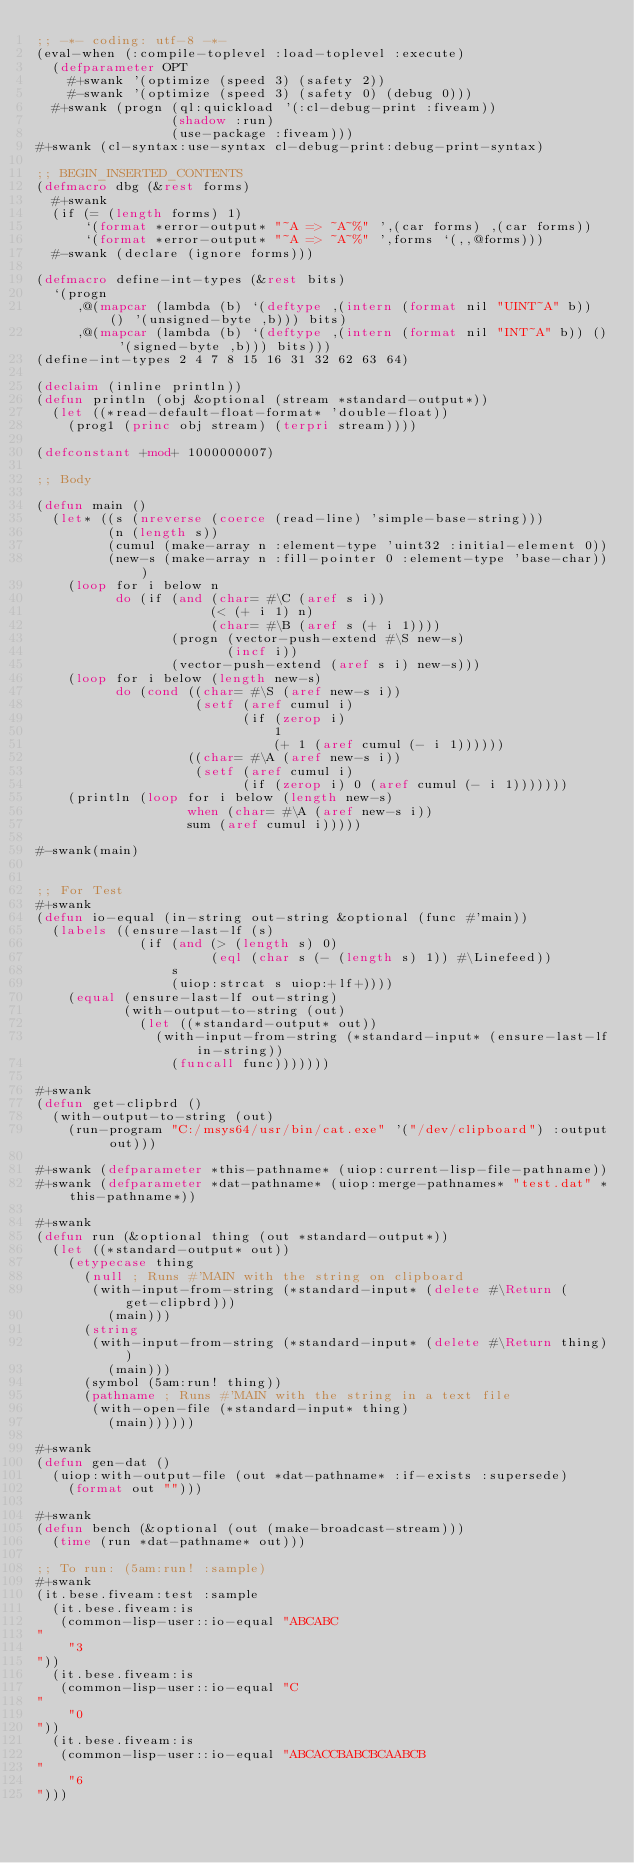Convert code to text. <code><loc_0><loc_0><loc_500><loc_500><_Lisp_>;; -*- coding: utf-8 -*-
(eval-when (:compile-toplevel :load-toplevel :execute)
  (defparameter OPT
    #+swank '(optimize (speed 3) (safety 2))
    #-swank '(optimize (speed 3) (safety 0) (debug 0)))
  #+swank (progn (ql:quickload '(:cl-debug-print :fiveam))
                 (shadow :run)
                 (use-package :fiveam)))
#+swank (cl-syntax:use-syntax cl-debug-print:debug-print-syntax)

;; BEGIN_INSERTED_CONTENTS
(defmacro dbg (&rest forms)
  #+swank
  (if (= (length forms) 1)
      `(format *error-output* "~A => ~A~%" ',(car forms) ,(car forms))
      `(format *error-output* "~A => ~A~%" ',forms `(,,@forms)))
  #-swank (declare (ignore forms)))

(defmacro define-int-types (&rest bits)
  `(progn
     ,@(mapcar (lambda (b) `(deftype ,(intern (format nil "UINT~A" b)) () '(unsigned-byte ,b))) bits)
     ,@(mapcar (lambda (b) `(deftype ,(intern (format nil "INT~A" b)) () '(signed-byte ,b))) bits)))
(define-int-types 2 4 7 8 15 16 31 32 62 63 64)

(declaim (inline println))
(defun println (obj &optional (stream *standard-output*))
  (let ((*read-default-float-format* 'double-float))
    (prog1 (princ obj stream) (terpri stream))))

(defconstant +mod+ 1000000007)

;; Body

(defun main ()
  (let* ((s (nreverse (coerce (read-line) 'simple-base-string)))
         (n (length s))
         (cumul (make-array n :element-type 'uint32 :initial-element 0))
         (new-s (make-array n :fill-pointer 0 :element-type 'base-char)))
    (loop for i below n
          do (if (and (char= #\C (aref s i))
                      (< (+ i 1) n)
                      (char= #\B (aref s (+ i 1))))
                 (progn (vector-push-extend #\S new-s)
                        (incf i))
                 (vector-push-extend (aref s i) new-s)))
    (loop for i below (length new-s)
          do (cond ((char= #\S (aref new-s i))
                    (setf (aref cumul i)
                          (if (zerop i)
                              1
                              (+ 1 (aref cumul (- i 1))))))
                   ((char= #\A (aref new-s i))
                    (setf (aref cumul i)
                          (if (zerop i) 0 (aref cumul (- i 1)))))))
    (println (loop for i below (length new-s)
                   when (char= #\A (aref new-s i))
                   sum (aref cumul i)))))

#-swank(main)


;; For Test
#+swank
(defun io-equal (in-string out-string &optional (func #'main))
  (labels ((ensure-last-lf (s)
             (if (and (> (length s) 0)
                      (eql (char s (- (length s) 1)) #\Linefeed))
                 s
                 (uiop:strcat s uiop:+lf+))))
    (equal (ensure-last-lf out-string)
           (with-output-to-string (out)
             (let ((*standard-output* out))
               (with-input-from-string (*standard-input* (ensure-last-lf in-string))
                 (funcall func)))))))

#+swank
(defun get-clipbrd ()
  (with-output-to-string (out)
    (run-program "C:/msys64/usr/bin/cat.exe" '("/dev/clipboard") :output out)))

#+swank (defparameter *this-pathname* (uiop:current-lisp-file-pathname))
#+swank (defparameter *dat-pathname* (uiop:merge-pathnames* "test.dat" *this-pathname*))

#+swank
(defun run (&optional thing (out *standard-output*))
  (let ((*standard-output* out))
    (etypecase thing
      (null ; Runs #'MAIN with the string on clipboard
       (with-input-from-string (*standard-input* (delete #\Return (get-clipbrd)))
         (main)))
      (string
       (with-input-from-string (*standard-input* (delete #\Return thing))
         (main)))
      (symbol (5am:run! thing))
      (pathname ; Runs #'MAIN with the string in a text file
       (with-open-file (*standard-input* thing)
         (main))))))

#+swank
(defun gen-dat ()
  (uiop:with-output-file (out *dat-pathname* :if-exists :supersede)
    (format out "")))

#+swank
(defun bench (&optional (out (make-broadcast-stream)))
  (time (run *dat-pathname* out)))

;; To run: (5am:run! :sample)
#+swank
(it.bese.fiveam:test :sample
  (it.bese.fiveam:is
   (common-lisp-user::io-equal "ABCABC
"
    "3
"))
  (it.bese.fiveam:is
   (common-lisp-user::io-equal "C
"
    "0
"))
  (it.bese.fiveam:is
   (common-lisp-user::io-equal "ABCACCBABCBCAABCB
"
    "6
")))
</code> 